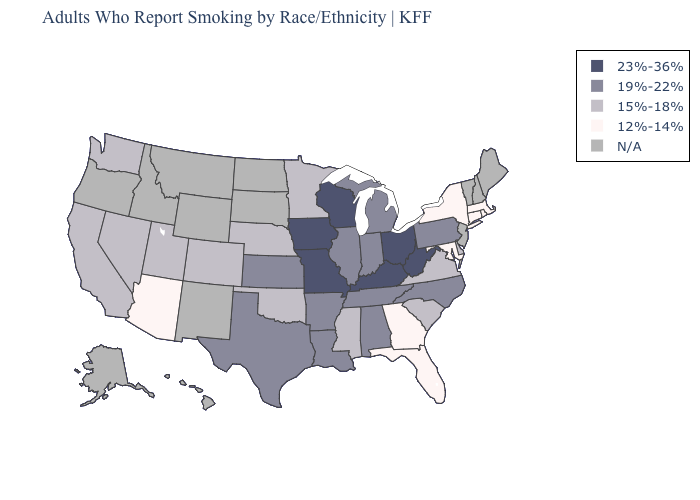Does Missouri have the lowest value in the USA?
Answer briefly. No. Is the legend a continuous bar?
Be succinct. No. Which states have the highest value in the USA?
Be succinct. Iowa, Kentucky, Missouri, Ohio, West Virginia, Wisconsin. Does Pennsylvania have the highest value in the Northeast?
Short answer required. Yes. Among the states that border Texas , does Louisiana have the highest value?
Short answer required. Yes. Name the states that have a value in the range 12%-14%?
Concise answer only. Arizona, Connecticut, Florida, Georgia, Maryland, Massachusetts, New York, Rhode Island. What is the lowest value in states that border Massachusetts?
Be succinct. 12%-14%. Name the states that have a value in the range N/A?
Write a very short answer. Alaska, Hawaii, Idaho, Maine, Montana, New Hampshire, New Jersey, New Mexico, North Dakota, Oregon, South Dakota, Vermont, Wyoming. Does Iowa have the highest value in the USA?
Concise answer only. Yes. Name the states that have a value in the range N/A?
Keep it brief. Alaska, Hawaii, Idaho, Maine, Montana, New Hampshire, New Jersey, New Mexico, North Dakota, Oregon, South Dakota, Vermont, Wyoming. What is the highest value in the USA?
Concise answer only. 23%-36%. Which states hav the highest value in the Northeast?
Short answer required. Pennsylvania. Among the states that border Ohio , does West Virginia have the highest value?
Be succinct. Yes. 